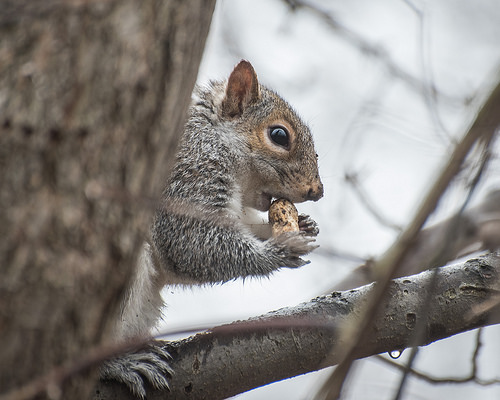<image>
Can you confirm if the squirrel is on the branch? Yes. Looking at the image, I can see the squirrel is positioned on top of the branch, with the branch providing support. Is the nut to the left of the tree? No. The nut is not to the left of the tree. From this viewpoint, they have a different horizontal relationship. Is there a squirrel in front of the branch? No. The squirrel is not in front of the branch. The spatial positioning shows a different relationship between these objects. Is the squirrel above the nut? Yes. The squirrel is positioned above the nut in the vertical space, higher up in the scene. 